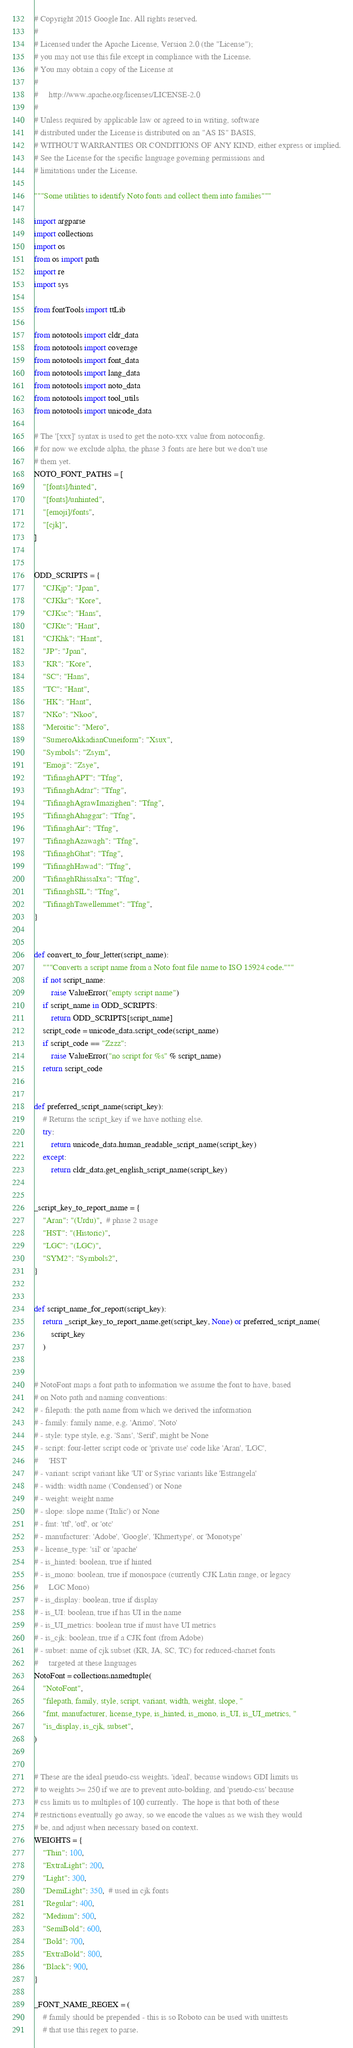<code> <loc_0><loc_0><loc_500><loc_500><_Python_># Copyright 2015 Google Inc. All rights reserved.
#
# Licensed under the Apache License, Version 2.0 (the "License");
# you may not use this file except in compliance with the License.
# You may obtain a copy of the License at
#
#     http://www.apache.org/licenses/LICENSE-2.0
#
# Unless required by applicable law or agreed to in writing, software
# distributed under the License is distributed on an "AS IS" BASIS,
# WITHOUT WARRANTIES OR CONDITIONS OF ANY KIND, either express or implied.
# See the License for the specific language governing permissions and
# limitations under the License.

"""Some utilities to identify Noto fonts and collect them into families"""

import argparse
import collections
import os
from os import path
import re
import sys

from fontTools import ttLib

from nototools import cldr_data
from nototools import coverage
from nototools import font_data
from nototools import lang_data
from nototools import noto_data
from nototools import tool_utils
from nototools import unicode_data

# The '[xxx]' syntax is used to get the noto-xxx value from notoconfig.
# for now we exclude alpha, the phase 3 fonts are here but we don't use
# them yet.
NOTO_FONT_PATHS = [
    "[fonts]/hinted",
    "[fonts]/unhinted",
    "[emoji]/fonts",
    "[cjk]",
]


ODD_SCRIPTS = {
    "CJKjp": "Jpan",
    "CJKkr": "Kore",
    "CJKsc": "Hans",
    "CJKtc": "Hant",
    "CJKhk": "Hant",
    "JP": "Jpan",
    "KR": "Kore",
    "SC": "Hans",
    "TC": "Hant",
    "HK": "Hant",
    "NKo": "Nkoo",
    "Meroitic": "Mero",
    "SumeroAkkadianCuneiform": "Xsux",
    "Symbols": "Zsym",
    "Emoji": "Zsye",
    "TifinaghAPT": "Tfng",
    "TifinaghAdrar": "Tfng",
    "TifinaghAgrawImazighen": "Tfng",
    "TifinaghAhaggar": "Tfng",
    "TifinaghAir": "Tfng",
    "TifinaghAzawagh": "Tfng",
    "TifinaghGhat": "Tfng",
    "TifinaghHawad": "Tfng",
    "TifinaghRhissaIxa": "Tfng",
    "TifinaghSIL": "Tfng",
    "TifinaghTawellemmet": "Tfng",
}


def convert_to_four_letter(script_name):
    """Converts a script name from a Noto font file name to ISO 15924 code."""
    if not script_name:
        raise ValueError("empty script name")
    if script_name in ODD_SCRIPTS:
        return ODD_SCRIPTS[script_name]
    script_code = unicode_data.script_code(script_name)
    if script_code == "Zzzz":
        raise ValueError("no script for %s" % script_name)
    return script_code


def preferred_script_name(script_key):
    # Returns the script_key if we have nothing else.
    try:
        return unicode_data.human_readable_script_name(script_key)
    except:
        return cldr_data.get_english_script_name(script_key)


_script_key_to_report_name = {
    "Aran": "(Urdu)",  # phase 2 usage
    "HST": "(Historic)",
    "LGC": "(LGC)",
    "SYM2": "Symbols2",
}


def script_name_for_report(script_key):
    return _script_key_to_report_name.get(script_key, None) or preferred_script_name(
        script_key
    )


# NotoFont maps a font path to information we assume the font to have, based
# on Noto path and naming conventions:
# - filepath: the path name from which we derived the information
# - family: family name, e.g. 'Arimo', 'Noto'
# - style: type style, e.g. 'Sans', 'Serif', might be None
# - script: four-letter script code or 'private use' code like 'Aran', 'LGC',
#     'HST'
# - variant: script variant like 'UI' or Syriac variants like 'Estrangela'
# - width: width name ('Condensed') or None
# - weight: weight name
# - slope: slope name ('Italic') or None
# - fmt: 'ttf', 'otf', or 'otc'
# - manufacturer: 'Adobe', 'Google', 'Khmertype', or 'Monotype'
# - license_type: 'sil' or 'apache'
# - is_hinted: boolean, true if hinted
# - is_mono: boolean, true if monospace (currently CJK Latin range, or legacy
#     LGC Mono)
# - is_display: boolean, true if display
# - is_UI: boolean, true if has UI in the name
# - is_UI_metrics: boolean true if must have UI metrics
# - is_cjk: boolean, true if a CJK font (from Adobe)
# - subset: name of cjk subset (KR, JA, SC, TC) for reduced-charset fonts
#     targeted at these languages
NotoFont = collections.namedtuple(
    "NotoFont",
    "filepath, family, style, script, variant, width, weight, slope, "
    "fmt, manufacturer, license_type, is_hinted, is_mono, is_UI, is_UI_metrics, "
    "is_display, is_cjk, subset",
)


# These are the ideal pseudo-css weights. 'ideal', because windows GDI limits us
# to weights >= 250 if we are to prevent auto-bolding, and 'pseudo-css' because
# css limits us to multiples of 100 currently.  The hope is that both of these
# restrictions eventually go away, so we encode the values as we wish they would
# be, and adjust when necessary based on context.
WEIGHTS = {
    "Thin": 100,
    "ExtraLight": 200,
    "Light": 300,
    "DemiLight": 350,  # used in cjk fonts
    "Regular": 400,
    "Medium": 500,
    "SemiBold": 600,
    "Bold": 700,
    "ExtraBold": 800,
    "Black": 900,
}

_FONT_NAME_REGEX = (
    # family should be prepended - this is so Roboto can be used with unittests
    # that use this regex to parse.</code> 